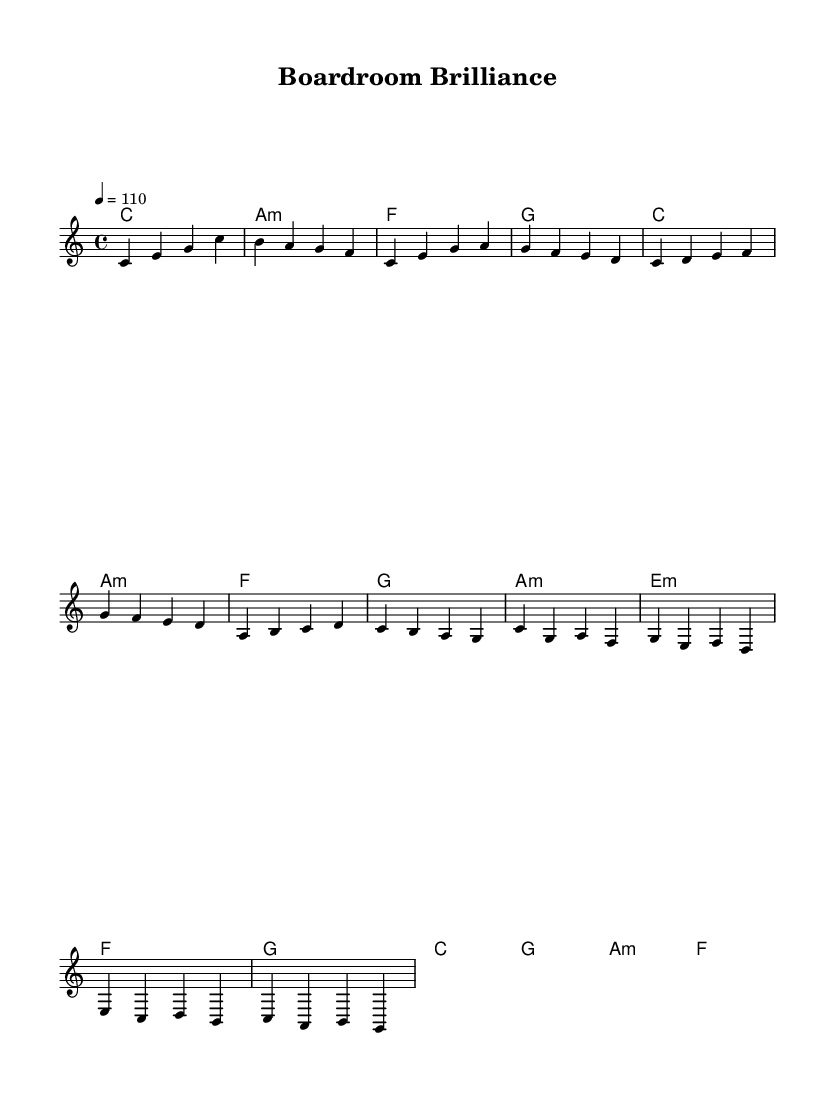What is the key signature of this music? The key signature is C major, which has no sharps or flats.
Answer: C major What is the time signature of this piece? The time signature is indicated by the number of beats in a measure; it shows 4 beats per measure.
Answer: 4/4 What is the tempo of this piece? The tempo is given as a metronome marking which indicates how fast the piece should be played. Here, it is 110 beats per minute.
Answer: 110 How many measures are in the melody section? To determine the number of measures, count the number of bar lines in the melody; there are 8 measures in the melody section.
Answer: 8 What chords are used in the chorus section? The chorus section can be identified based on its position, and the chords listed during that part are C major, G major, A minor, and F major.
Answer: C, G, A minor, F What is the structure of the piece based on sections? The piece is structured with distinct sections: an intro, verse, bridge, and chorus. Each of these serves a specific musical purpose contributing to the overall flow.
Answer: Intro, Verse, Bridge, Chorus Which two chords are used repeatedly in the verse section? The chords used repeatedly in the verse reflect common harmonic progressions; in this case, C major and A minor appear multiple times.
Answer: C major, A minor 